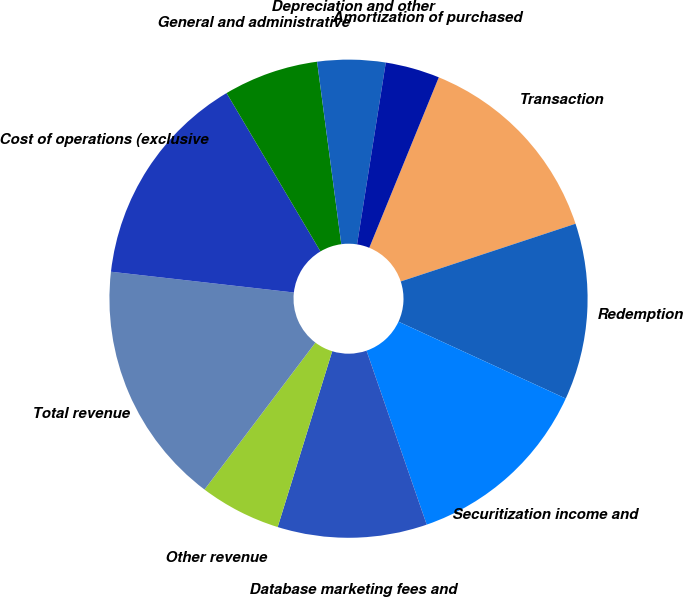Convert chart to OTSL. <chart><loc_0><loc_0><loc_500><loc_500><pie_chart><fcel>Transaction<fcel>Redemption<fcel>Securitization income and<fcel>Database marketing fees and<fcel>Other revenue<fcel>Total revenue<fcel>Cost of operations (exclusive<fcel>General and administrative<fcel>Depreciation and other<fcel>Amortization of purchased<nl><fcel>13.76%<fcel>11.93%<fcel>12.84%<fcel>10.09%<fcel>5.5%<fcel>16.51%<fcel>14.68%<fcel>6.42%<fcel>4.59%<fcel>3.67%<nl></chart> 